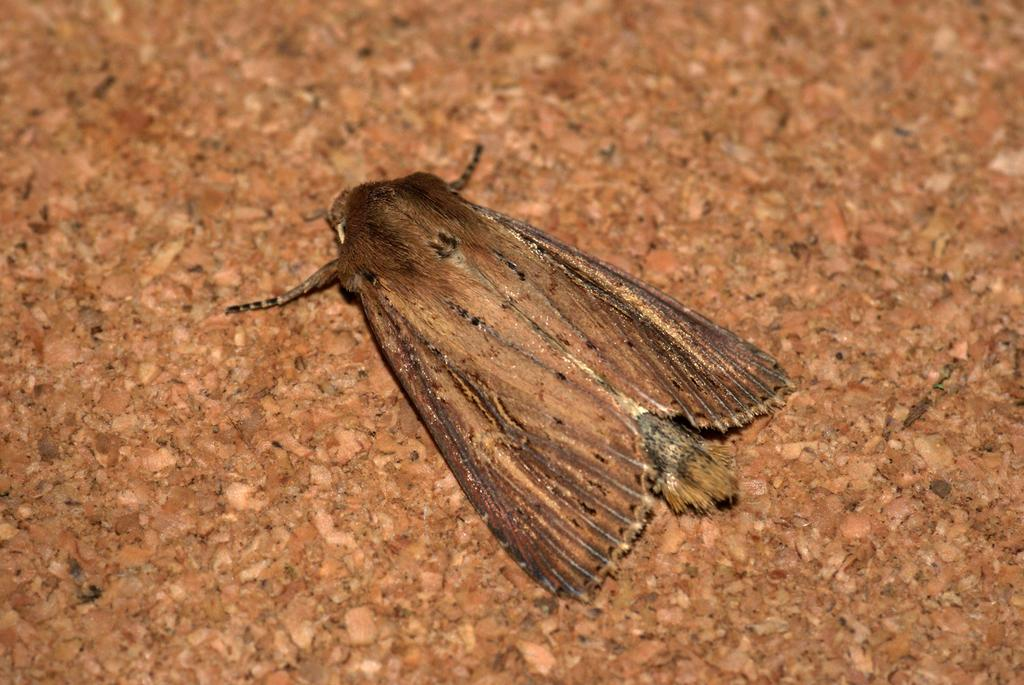What type of creature can be seen in the image? There is an insect in the image. What is the insect located on in the image? The insect is on an object. How does the insect help with washing dishes in the image? The insect does not help with washing dishes in the image, as it is not a tool or person involved in that activity. 